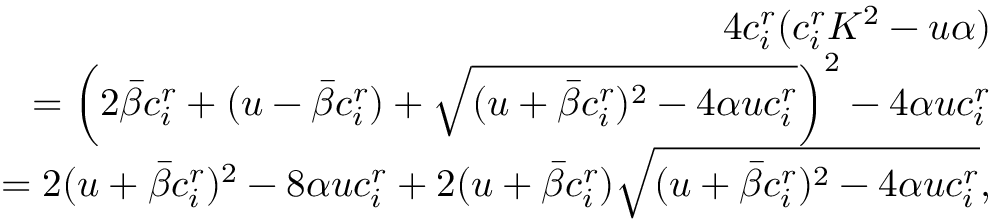<formula> <loc_0><loc_0><loc_500><loc_500>\begin{array} { r } { 4 c _ { i } ^ { r } ( c _ { i } ^ { r } K ^ { 2 } - { u \alpha } ) } \\ { = \left ( 2 \bar { \beta } c _ { i } ^ { r } + ( u - \bar { \beta } c _ { i } ^ { r } ) + \sqrt { ( u + \bar { \beta } c _ { i } ^ { r } ) ^ { 2 } - 4 \alpha u c _ { i } ^ { r } } \right ) ^ { 2 } - 4 \alpha u c _ { i } ^ { r } } \\ { = 2 ( u + \bar { \beta } c _ { i } ^ { r } ) ^ { 2 } - 8 \alpha u c _ { i } ^ { r } + 2 ( u + \bar { \beta } c _ { i } ^ { r } ) \sqrt { ( u + \bar { \beta } c _ { i } ^ { r } ) ^ { 2 } - 4 \alpha u c _ { i } ^ { r } } , } \end{array}</formula> 